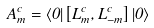Convert formula to latex. <formula><loc_0><loc_0><loc_500><loc_500>A _ { m } ^ { c } = \langle 0 | \left [ L _ { m } ^ { c } , L _ { - m } ^ { c } \right ] | 0 \rangle</formula> 